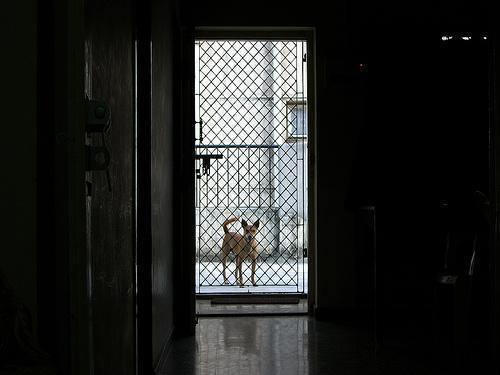How many dogs are there?
Give a very brief answer. 1. How many windows are there?
Give a very brief answer. 0. How many windows on this bus face toward the traffic behind it?
Give a very brief answer. 0. 